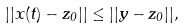Convert formula to latex. <formula><loc_0><loc_0><loc_500><loc_500>| | x ( t ) - z _ { 0 } | | \leq | | y - z _ { 0 } | | ,</formula> 